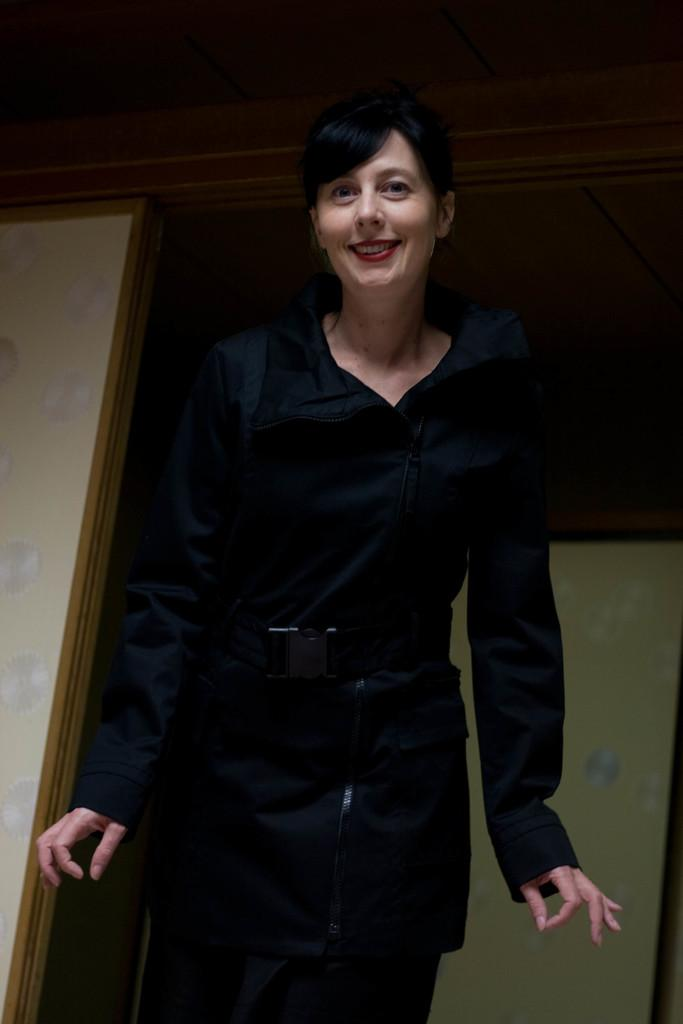Who is present in the image? There is a woman in the image. What is the woman doing in the image? The woman is standing. What is the woman wearing in the image? The woman is wearing clothes. What type of soup is being served from the engine in the image? There is no soup or engine present in the image. What type of door can be seen in the image? There is no door present in the image. 